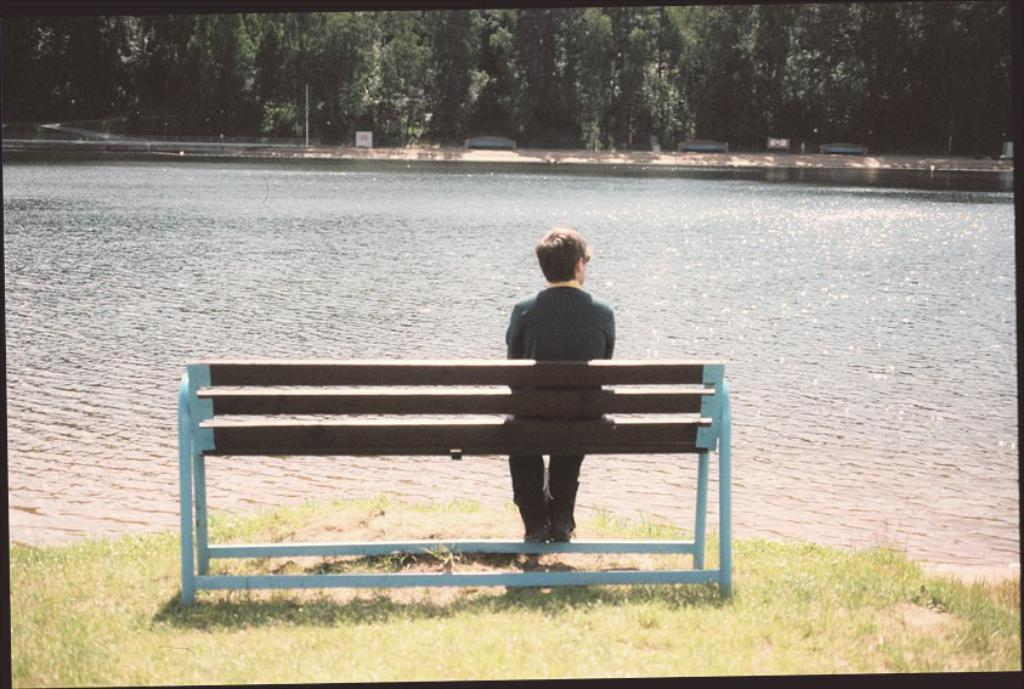What is the man in the image doing? The man is sitting on a bench in the image. What type of water body is present in the image? The image contains a freshwater river. What can be seen in the distance in the image? There are trees visible in the distance. What is the color of the grass in the image? The grass is green in color. What type of behavior is the boy exhibiting in the image? There is no boy present in the image, only a man sitting on a bench. What color is the stocking worn by the person in the image? There is no stocking visible in the image; the man is sitting on a bench with no visible clothing items on his legs. 